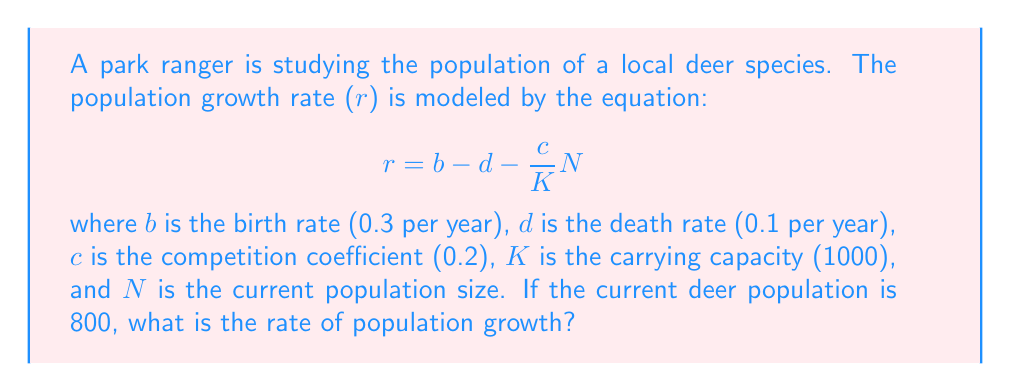Solve this math problem. To solve this problem, we'll follow these steps:

1. Identify the given values:
   b = 0.3 per year
   d = 0.1 per year
   c = 0.2
   K = 1000
   N = 800

2. Substitute these values into the equation:
   $$r = b - d - \frac{c}{K}N$$

3. Calculate the term $\frac{c}{K}N$:
   $$\frac{c}{K}N = \frac{0.2}{1000} \times 800 = 0.16$$

4. Substitute this result into the equation:
   $$r = 0.3 - 0.1 - 0.16$$

5. Perform the final calculation:
   $$r = 0.04$$

Therefore, the rate of population growth for the deer species is 0.04 per year, or 4% per year.
Answer: 0.04 per year 